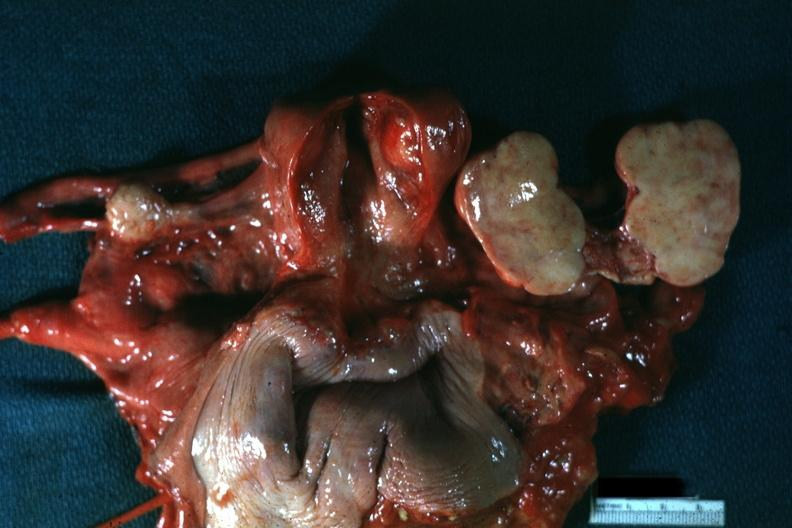what is all pelvic organs tumor mass opened?
Answer the question using a single word or phrase. Like a book typical for this lesion 